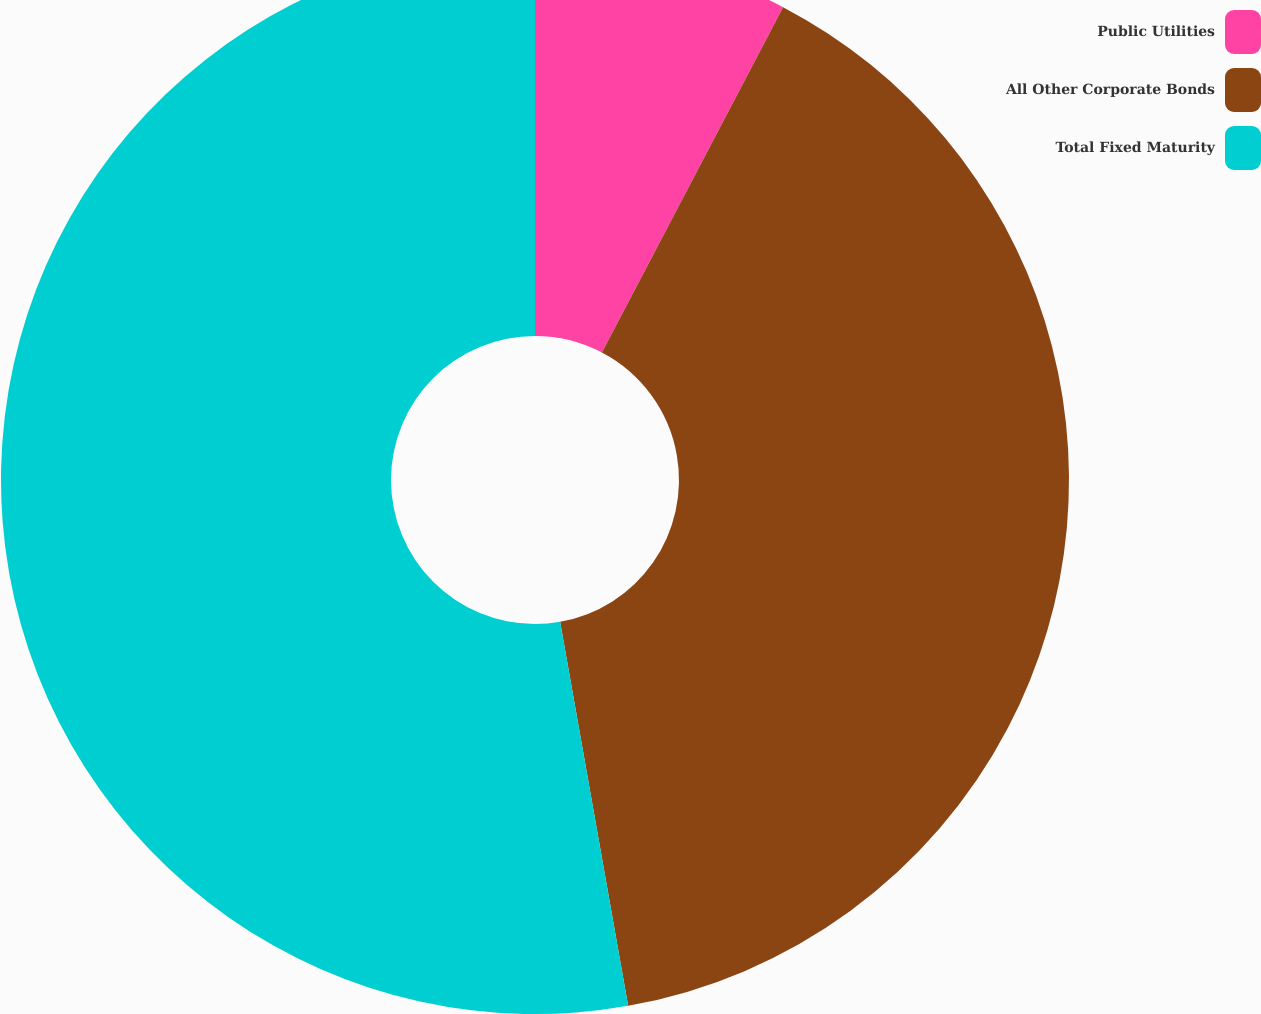Convert chart to OTSL. <chart><loc_0><loc_0><loc_500><loc_500><pie_chart><fcel>Public Utilities<fcel>All Other Corporate Bonds<fcel>Total Fixed Maturity<nl><fcel>7.69%<fcel>39.52%<fcel>52.79%<nl></chart> 